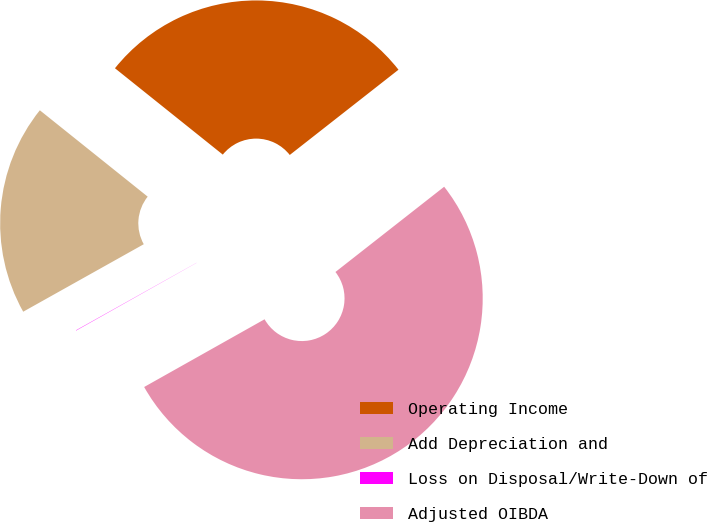Convert chart. <chart><loc_0><loc_0><loc_500><loc_500><pie_chart><fcel>Operating Income<fcel>Add Depreciation and<fcel>Loss on Disposal/Write-Down of<fcel>Adjusted OIBDA<nl><fcel>28.67%<fcel>18.87%<fcel>0.03%<fcel>52.43%<nl></chart> 